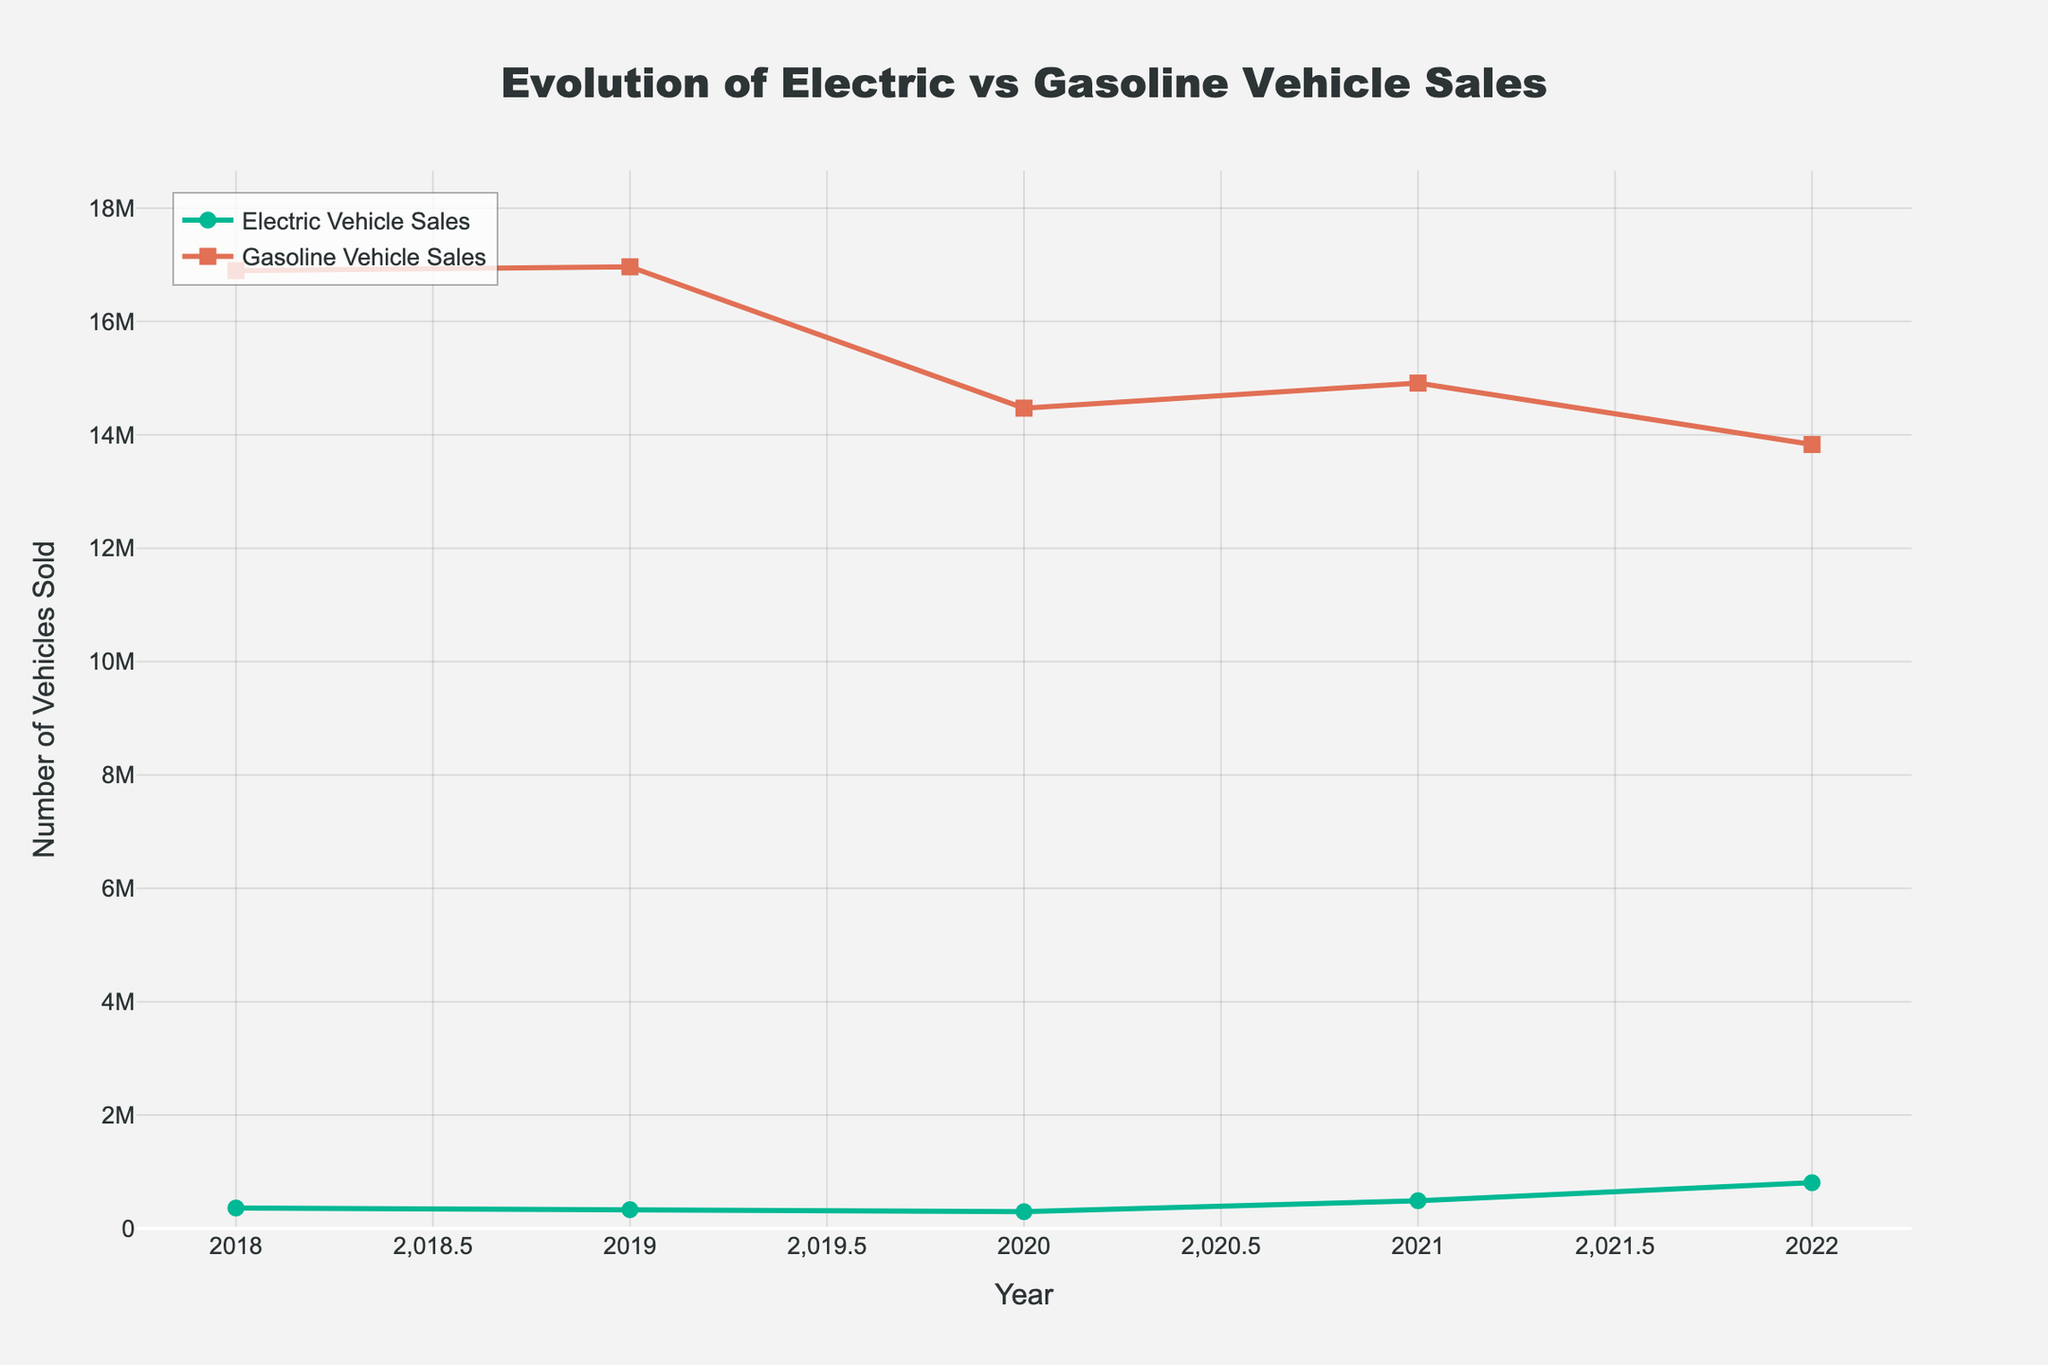Which year had the highest electric vehicle sales? By looking at the peak of the line representing electric vehicle sales, we can determine that the highest peak occurs in 2022.
Answer: 2022 How many more gasoline vehicles were sold than electric vehicles in 2021? Compare the values for gasoline vehicle sales and electric vehicle sales for the year 2021. Subtract the electric vehicle sales (489734) from gasoline vehicle sales (14913722). The difference is 14424088.
Answer: 14424088 What is the average number of electric vehicle sales over the 5 years? Add the electric vehicle sales for each year and divide by the number of years (5). (361307 + 331977 + 296031 + 489734 + 807180) = 2282229. Divide by 5 to get the average, which is 456445.8.
Answer: 456446 In which year did electric vehicles achieve the largest market share percentage? Look for the highest value in the "EV Market Share (%)" column. The highest value is 5.5% in 2022, indicating that 2022 had the largest market share percentage for electric vehicles.
Answer: 2022 During which year did both electric vehicle sales and gasoline vehicle sales decline compared to the previous year? Compare sales figures for each year to the previous year. In 2019, both electric vehicle sales (361307 in 2018 to 331977 in 2019) and gasoline vehicle sales (16897721 in 2018 to 16965163 in 2019) showed a decline.
Answer: 2019 Which year had the closest sales figures between Toyota Camry and Tesla Model 3? Compare the sales figures for both Toyota Camry and Tesla Model 3 for each year. The year with the closest figures is 2022, where Toyota Camry had 295201 and Tesla Model 3 had 238533, with a difference of 56668.
Answer: 2022 By how much did electric vehicle sales increase from 2020 to 2022? Subtract electric vehicle sales in 2020 from 2022. (807180 in 2022 - 296031 in 2020) = 511149.
Answer: 511149 Did gasoline vehicle sales increase or decrease overall from 2018 to 2022? Compare the gasoline vehicle sales in 2018 (16897721) with sales in 2022 (13830172). The value decreased.
Answer: Decrease Which year saw the highest decline in gasoline vehicle sales compared to the previous year? Calculate the year-on-year differences for gasoline vehicle sales and find the largest negative difference. The largest decline occurred between 2019 (16965163) and 2020 (14471805), a decline of 2493358.
Answer: 2020 What is the total number of vehicles (both electric and gasoline) sold in 2022? Add the electric vehicle sales and gasoline vehicle sales for 2022. (807180 electric + 13830172 gasoline) = 14637352 total vehicles.
Answer: 14637352 